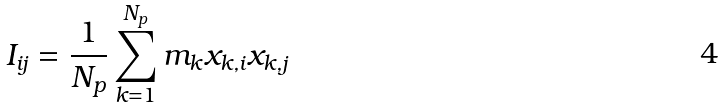Convert formula to latex. <formula><loc_0><loc_0><loc_500><loc_500>I _ { i j } = \frac { 1 } { N _ { p } } \sum _ { k = 1 } ^ { N _ { p } } m _ { k } x _ { k , i } x _ { k , j }</formula> 